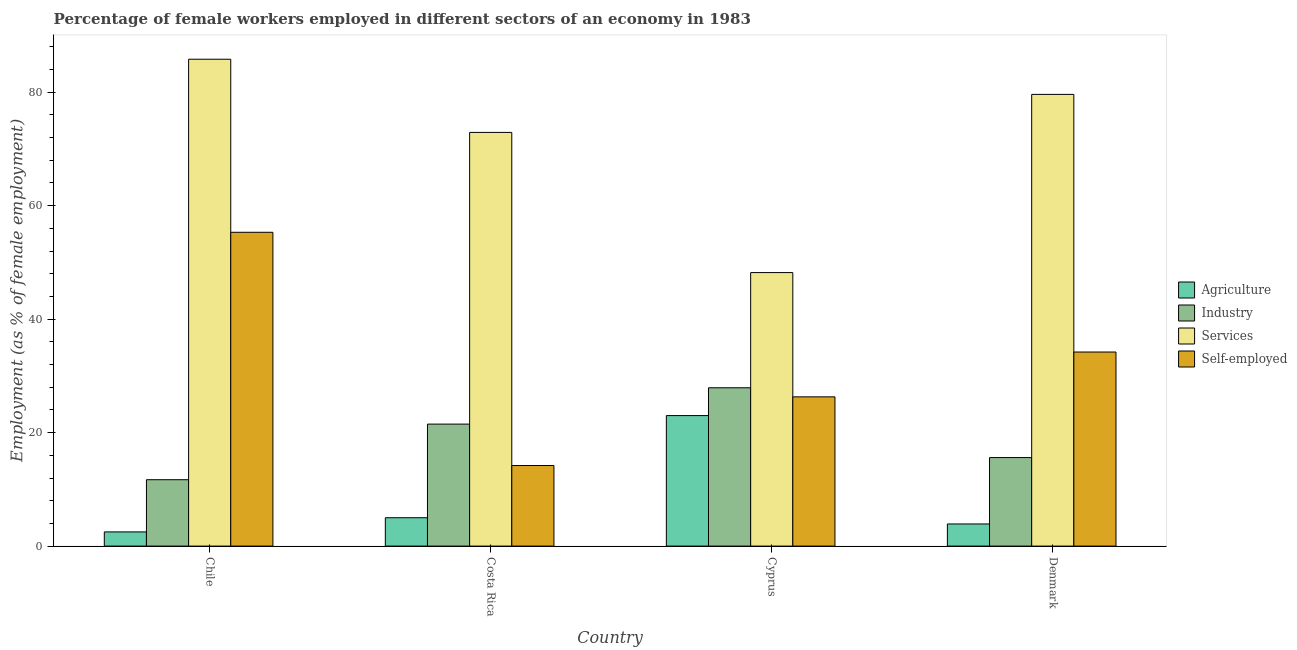How many groups of bars are there?
Make the answer very short. 4. Are the number of bars per tick equal to the number of legend labels?
Offer a very short reply. Yes. How many bars are there on the 1st tick from the left?
Keep it short and to the point. 4. What is the label of the 2nd group of bars from the left?
Your answer should be compact. Costa Rica. What is the percentage of female workers in industry in Denmark?
Ensure brevity in your answer.  15.6. Across all countries, what is the maximum percentage of self employed female workers?
Provide a short and direct response. 55.3. Across all countries, what is the minimum percentage of female workers in industry?
Make the answer very short. 11.7. In which country was the percentage of female workers in agriculture maximum?
Ensure brevity in your answer.  Cyprus. In which country was the percentage of self employed female workers minimum?
Keep it short and to the point. Costa Rica. What is the total percentage of female workers in industry in the graph?
Ensure brevity in your answer.  76.7. What is the difference between the percentage of female workers in industry in Chile and that in Cyprus?
Keep it short and to the point. -16.2. What is the difference between the percentage of female workers in services in Denmark and the percentage of female workers in agriculture in Cyprus?
Keep it short and to the point. 56.6. What is the average percentage of female workers in agriculture per country?
Provide a short and direct response. 8.6. What is the difference between the percentage of female workers in industry and percentage of female workers in services in Costa Rica?
Your response must be concise. -51.4. What is the ratio of the percentage of female workers in agriculture in Chile to that in Costa Rica?
Keep it short and to the point. 0.5. What is the difference between the highest and the second highest percentage of female workers in services?
Your response must be concise. 6.2. What is the difference between the highest and the lowest percentage of self employed female workers?
Offer a very short reply. 41.1. Is it the case that in every country, the sum of the percentage of self employed female workers and percentage of female workers in industry is greater than the sum of percentage of female workers in services and percentage of female workers in agriculture?
Keep it short and to the point. No. What does the 3rd bar from the left in Costa Rica represents?
Ensure brevity in your answer.  Services. What does the 1st bar from the right in Chile represents?
Provide a short and direct response. Self-employed. Is it the case that in every country, the sum of the percentage of female workers in agriculture and percentage of female workers in industry is greater than the percentage of female workers in services?
Make the answer very short. No. How many bars are there?
Ensure brevity in your answer.  16. Are all the bars in the graph horizontal?
Provide a succinct answer. No. What is the difference between two consecutive major ticks on the Y-axis?
Provide a succinct answer. 20. Are the values on the major ticks of Y-axis written in scientific E-notation?
Offer a terse response. No. How are the legend labels stacked?
Provide a succinct answer. Vertical. What is the title of the graph?
Offer a terse response. Percentage of female workers employed in different sectors of an economy in 1983. Does "Custom duties" appear as one of the legend labels in the graph?
Your answer should be very brief. No. What is the label or title of the X-axis?
Your response must be concise. Country. What is the label or title of the Y-axis?
Keep it short and to the point. Employment (as % of female employment). What is the Employment (as % of female employment) of Agriculture in Chile?
Your response must be concise. 2.5. What is the Employment (as % of female employment) in Industry in Chile?
Give a very brief answer. 11.7. What is the Employment (as % of female employment) in Services in Chile?
Offer a very short reply. 85.8. What is the Employment (as % of female employment) in Self-employed in Chile?
Offer a terse response. 55.3. What is the Employment (as % of female employment) in Industry in Costa Rica?
Ensure brevity in your answer.  21.5. What is the Employment (as % of female employment) of Services in Costa Rica?
Provide a succinct answer. 72.9. What is the Employment (as % of female employment) of Self-employed in Costa Rica?
Make the answer very short. 14.2. What is the Employment (as % of female employment) of Agriculture in Cyprus?
Your answer should be very brief. 23. What is the Employment (as % of female employment) of Industry in Cyprus?
Offer a terse response. 27.9. What is the Employment (as % of female employment) of Services in Cyprus?
Offer a very short reply. 48.2. What is the Employment (as % of female employment) in Self-employed in Cyprus?
Provide a short and direct response. 26.3. What is the Employment (as % of female employment) in Agriculture in Denmark?
Offer a very short reply. 3.9. What is the Employment (as % of female employment) of Industry in Denmark?
Your answer should be compact. 15.6. What is the Employment (as % of female employment) of Services in Denmark?
Keep it short and to the point. 79.6. What is the Employment (as % of female employment) of Self-employed in Denmark?
Your answer should be compact. 34.2. Across all countries, what is the maximum Employment (as % of female employment) of Agriculture?
Provide a short and direct response. 23. Across all countries, what is the maximum Employment (as % of female employment) of Industry?
Offer a very short reply. 27.9. Across all countries, what is the maximum Employment (as % of female employment) in Services?
Make the answer very short. 85.8. Across all countries, what is the maximum Employment (as % of female employment) of Self-employed?
Your answer should be compact. 55.3. Across all countries, what is the minimum Employment (as % of female employment) of Industry?
Ensure brevity in your answer.  11.7. Across all countries, what is the minimum Employment (as % of female employment) in Services?
Make the answer very short. 48.2. Across all countries, what is the minimum Employment (as % of female employment) in Self-employed?
Your response must be concise. 14.2. What is the total Employment (as % of female employment) of Agriculture in the graph?
Your response must be concise. 34.4. What is the total Employment (as % of female employment) of Industry in the graph?
Provide a succinct answer. 76.7. What is the total Employment (as % of female employment) in Services in the graph?
Provide a succinct answer. 286.5. What is the total Employment (as % of female employment) of Self-employed in the graph?
Provide a short and direct response. 130. What is the difference between the Employment (as % of female employment) of Agriculture in Chile and that in Costa Rica?
Your answer should be very brief. -2.5. What is the difference between the Employment (as % of female employment) of Services in Chile and that in Costa Rica?
Offer a very short reply. 12.9. What is the difference between the Employment (as % of female employment) in Self-employed in Chile and that in Costa Rica?
Your answer should be compact. 41.1. What is the difference between the Employment (as % of female employment) in Agriculture in Chile and that in Cyprus?
Make the answer very short. -20.5. What is the difference between the Employment (as % of female employment) of Industry in Chile and that in Cyprus?
Your response must be concise. -16.2. What is the difference between the Employment (as % of female employment) in Services in Chile and that in Cyprus?
Keep it short and to the point. 37.6. What is the difference between the Employment (as % of female employment) of Self-employed in Chile and that in Cyprus?
Offer a very short reply. 29. What is the difference between the Employment (as % of female employment) of Services in Chile and that in Denmark?
Make the answer very short. 6.2. What is the difference between the Employment (as % of female employment) of Self-employed in Chile and that in Denmark?
Provide a short and direct response. 21.1. What is the difference between the Employment (as % of female employment) of Services in Costa Rica and that in Cyprus?
Your answer should be compact. 24.7. What is the difference between the Employment (as % of female employment) of Self-employed in Costa Rica and that in Cyprus?
Keep it short and to the point. -12.1. What is the difference between the Employment (as % of female employment) of Agriculture in Costa Rica and that in Denmark?
Your answer should be compact. 1.1. What is the difference between the Employment (as % of female employment) of Self-employed in Costa Rica and that in Denmark?
Keep it short and to the point. -20. What is the difference between the Employment (as % of female employment) of Agriculture in Cyprus and that in Denmark?
Offer a very short reply. 19.1. What is the difference between the Employment (as % of female employment) in Services in Cyprus and that in Denmark?
Your response must be concise. -31.4. What is the difference between the Employment (as % of female employment) in Self-employed in Cyprus and that in Denmark?
Give a very brief answer. -7.9. What is the difference between the Employment (as % of female employment) in Agriculture in Chile and the Employment (as % of female employment) in Industry in Costa Rica?
Your answer should be very brief. -19. What is the difference between the Employment (as % of female employment) in Agriculture in Chile and the Employment (as % of female employment) in Services in Costa Rica?
Your response must be concise. -70.4. What is the difference between the Employment (as % of female employment) in Agriculture in Chile and the Employment (as % of female employment) in Self-employed in Costa Rica?
Ensure brevity in your answer.  -11.7. What is the difference between the Employment (as % of female employment) of Industry in Chile and the Employment (as % of female employment) of Services in Costa Rica?
Provide a short and direct response. -61.2. What is the difference between the Employment (as % of female employment) in Industry in Chile and the Employment (as % of female employment) in Self-employed in Costa Rica?
Offer a very short reply. -2.5. What is the difference between the Employment (as % of female employment) in Services in Chile and the Employment (as % of female employment) in Self-employed in Costa Rica?
Your answer should be very brief. 71.6. What is the difference between the Employment (as % of female employment) of Agriculture in Chile and the Employment (as % of female employment) of Industry in Cyprus?
Offer a very short reply. -25.4. What is the difference between the Employment (as % of female employment) of Agriculture in Chile and the Employment (as % of female employment) of Services in Cyprus?
Make the answer very short. -45.7. What is the difference between the Employment (as % of female employment) of Agriculture in Chile and the Employment (as % of female employment) of Self-employed in Cyprus?
Give a very brief answer. -23.8. What is the difference between the Employment (as % of female employment) in Industry in Chile and the Employment (as % of female employment) in Services in Cyprus?
Offer a very short reply. -36.5. What is the difference between the Employment (as % of female employment) in Industry in Chile and the Employment (as % of female employment) in Self-employed in Cyprus?
Your response must be concise. -14.6. What is the difference between the Employment (as % of female employment) of Services in Chile and the Employment (as % of female employment) of Self-employed in Cyprus?
Your answer should be compact. 59.5. What is the difference between the Employment (as % of female employment) of Agriculture in Chile and the Employment (as % of female employment) of Services in Denmark?
Give a very brief answer. -77.1. What is the difference between the Employment (as % of female employment) in Agriculture in Chile and the Employment (as % of female employment) in Self-employed in Denmark?
Keep it short and to the point. -31.7. What is the difference between the Employment (as % of female employment) in Industry in Chile and the Employment (as % of female employment) in Services in Denmark?
Offer a terse response. -67.9. What is the difference between the Employment (as % of female employment) of Industry in Chile and the Employment (as % of female employment) of Self-employed in Denmark?
Your response must be concise. -22.5. What is the difference between the Employment (as % of female employment) of Services in Chile and the Employment (as % of female employment) of Self-employed in Denmark?
Your response must be concise. 51.6. What is the difference between the Employment (as % of female employment) of Agriculture in Costa Rica and the Employment (as % of female employment) of Industry in Cyprus?
Ensure brevity in your answer.  -22.9. What is the difference between the Employment (as % of female employment) in Agriculture in Costa Rica and the Employment (as % of female employment) in Services in Cyprus?
Make the answer very short. -43.2. What is the difference between the Employment (as % of female employment) of Agriculture in Costa Rica and the Employment (as % of female employment) of Self-employed in Cyprus?
Ensure brevity in your answer.  -21.3. What is the difference between the Employment (as % of female employment) in Industry in Costa Rica and the Employment (as % of female employment) in Services in Cyprus?
Ensure brevity in your answer.  -26.7. What is the difference between the Employment (as % of female employment) in Services in Costa Rica and the Employment (as % of female employment) in Self-employed in Cyprus?
Your answer should be compact. 46.6. What is the difference between the Employment (as % of female employment) in Agriculture in Costa Rica and the Employment (as % of female employment) in Services in Denmark?
Provide a short and direct response. -74.6. What is the difference between the Employment (as % of female employment) of Agriculture in Costa Rica and the Employment (as % of female employment) of Self-employed in Denmark?
Offer a very short reply. -29.2. What is the difference between the Employment (as % of female employment) in Industry in Costa Rica and the Employment (as % of female employment) in Services in Denmark?
Your answer should be compact. -58.1. What is the difference between the Employment (as % of female employment) in Services in Costa Rica and the Employment (as % of female employment) in Self-employed in Denmark?
Your answer should be very brief. 38.7. What is the difference between the Employment (as % of female employment) of Agriculture in Cyprus and the Employment (as % of female employment) of Industry in Denmark?
Ensure brevity in your answer.  7.4. What is the difference between the Employment (as % of female employment) of Agriculture in Cyprus and the Employment (as % of female employment) of Services in Denmark?
Ensure brevity in your answer.  -56.6. What is the difference between the Employment (as % of female employment) in Industry in Cyprus and the Employment (as % of female employment) in Services in Denmark?
Offer a very short reply. -51.7. What is the average Employment (as % of female employment) of Agriculture per country?
Your answer should be very brief. 8.6. What is the average Employment (as % of female employment) of Industry per country?
Your answer should be very brief. 19.18. What is the average Employment (as % of female employment) in Services per country?
Give a very brief answer. 71.62. What is the average Employment (as % of female employment) in Self-employed per country?
Your answer should be very brief. 32.5. What is the difference between the Employment (as % of female employment) in Agriculture and Employment (as % of female employment) in Services in Chile?
Ensure brevity in your answer.  -83.3. What is the difference between the Employment (as % of female employment) in Agriculture and Employment (as % of female employment) in Self-employed in Chile?
Your answer should be very brief. -52.8. What is the difference between the Employment (as % of female employment) in Industry and Employment (as % of female employment) in Services in Chile?
Offer a very short reply. -74.1. What is the difference between the Employment (as % of female employment) of Industry and Employment (as % of female employment) of Self-employed in Chile?
Make the answer very short. -43.6. What is the difference between the Employment (as % of female employment) in Services and Employment (as % of female employment) in Self-employed in Chile?
Ensure brevity in your answer.  30.5. What is the difference between the Employment (as % of female employment) of Agriculture and Employment (as % of female employment) of Industry in Costa Rica?
Provide a short and direct response. -16.5. What is the difference between the Employment (as % of female employment) of Agriculture and Employment (as % of female employment) of Services in Costa Rica?
Offer a very short reply. -67.9. What is the difference between the Employment (as % of female employment) in Industry and Employment (as % of female employment) in Services in Costa Rica?
Keep it short and to the point. -51.4. What is the difference between the Employment (as % of female employment) of Services and Employment (as % of female employment) of Self-employed in Costa Rica?
Give a very brief answer. 58.7. What is the difference between the Employment (as % of female employment) in Agriculture and Employment (as % of female employment) in Services in Cyprus?
Ensure brevity in your answer.  -25.2. What is the difference between the Employment (as % of female employment) of Agriculture and Employment (as % of female employment) of Self-employed in Cyprus?
Ensure brevity in your answer.  -3.3. What is the difference between the Employment (as % of female employment) in Industry and Employment (as % of female employment) in Services in Cyprus?
Your answer should be very brief. -20.3. What is the difference between the Employment (as % of female employment) in Services and Employment (as % of female employment) in Self-employed in Cyprus?
Your answer should be very brief. 21.9. What is the difference between the Employment (as % of female employment) in Agriculture and Employment (as % of female employment) in Services in Denmark?
Provide a succinct answer. -75.7. What is the difference between the Employment (as % of female employment) in Agriculture and Employment (as % of female employment) in Self-employed in Denmark?
Ensure brevity in your answer.  -30.3. What is the difference between the Employment (as % of female employment) in Industry and Employment (as % of female employment) in Services in Denmark?
Make the answer very short. -64. What is the difference between the Employment (as % of female employment) in Industry and Employment (as % of female employment) in Self-employed in Denmark?
Make the answer very short. -18.6. What is the difference between the Employment (as % of female employment) in Services and Employment (as % of female employment) in Self-employed in Denmark?
Provide a short and direct response. 45.4. What is the ratio of the Employment (as % of female employment) of Agriculture in Chile to that in Costa Rica?
Give a very brief answer. 0.5. What is the ratio of the Employment (as % of female employment) in Industry in Chile to that in Costa Rica?
Offer a very short reply. 0.54. What is the ratio of the Employment (as % of female employment) in Services in Chile to that in Costa Rica?
Ensure brevity in your answer.  1.18. What is the ratio of the Employment (as % of female employment) in Self-employed in Chile to that in Costa Rica?
Offer a terse response. 3.89. What is the ratio of the Employment (as % of female employment) of Agriculture in Chile to that in Cyprus?
Keep it short and to the point. 0.11. What is the ratio of the Employment (as % of female employment) in Industry in Chile to that in Cyprus?
Your answer should be compact. 0.42. What is the ratio of the Employment (as % of female employment) of Services in Chile to that in Cyprus?
Your response must be concise. 1.78. What is the ratio of the Employment (as % of female employment) in Self-employed in Chile to that in Cyprus?
Offer a very short reply. 2.1. What is the ratio of the Employment (as % of female employment) of Agriculture in Chile to that in Denmark?
Your answer should be compact. 0.64. What is the ratio of the Employment (as % of female employment) of Services in Chile to that in Denmark?
Your answer should be compact. 1.08. What is the ratio of the Employment (as % of female employment) of Self-employed in Chile to that in Denmark?
Offer a very short reply. 1.62. What is the ratio of the Employment (as % of female employment) of Agriculture in Costa Rica to that in Cyprus?
Keep it short and to the point. 0.22. What is the ratio of the Employment (as % of female employment) in Industry in Costa Rica to that in Cyprus?
Offer a terse response. 0.77. What is the ratio of the Employment (as % of female employment) in Services in Costa Rica to that in Cyprus?
Offer a terse response. 1.51. What is the ratio of the Employment (as % of female employment) of Self-employed in Costa Rica to that in Cyprus?
Your answer should be very brief. 0.54. What is the ratio of the Employment (as % of female employment) of Agriculture in Costa Rica to that in Denmark?
Provide a succinct answer. 1.28. What is the ratio of the Employment (as % of female employment) in Industry in Costa Rica to that in Denmark?
Keep it short and to the point. 1.38. What is the ratio of the Employment (as % of female employment) in Services in Costa Rica to that in Denmark?
Your response must be concise. 0.92. What is the ratio of the Employment (as % of female employment) of Self-employed in Costa Rica to that in Denmark?
Keep it short and to the point. 0.42. What is the ratio of the Employment (as % of female employment) of Agriculture in Cyprus to that in Denmark?
Your answer should be very brief. 5.9. What is the ratio of the Employment (as % of female employment) in Industry in Cyprus to that in Denmark?
Ensure brevity in your answer.  1.79. What is the ratio of the Employment (as % of female employment) of Services in Cyprus to that in Denmark?
Offer a very short reply. 0.61. What is the ratio of the Employment (as % of female employment) of Self-employed in Cyprus to that in Denmark?
Your answer should be very brief. 0.77. What is the difference between the highest and the second highest Employment (as % of female employment) of Agriculture?
Keep it short and to the point. 18. What is the difference between the highest and the second highest Employment (as % of female employment) in Industry?
Give a very brief answer. 6.4. What is the difference between the highest and the second highest Employment (as % of female employment) of Self-employed?
Provide a succinct answer. 21.1. What is the difference between the highest and the lowest Employment (as % of female employment) of Industry?
Keep it short and to the point. 16.2. What is the difference between the highest and the lowest Employment (as % of female employment) in Services?
Provide a short and direct response. 37.6. What is the difference between the highest and the lowest Employment (as % of female employment) of Self-employed?
Your answer should be compact. 41.1. 